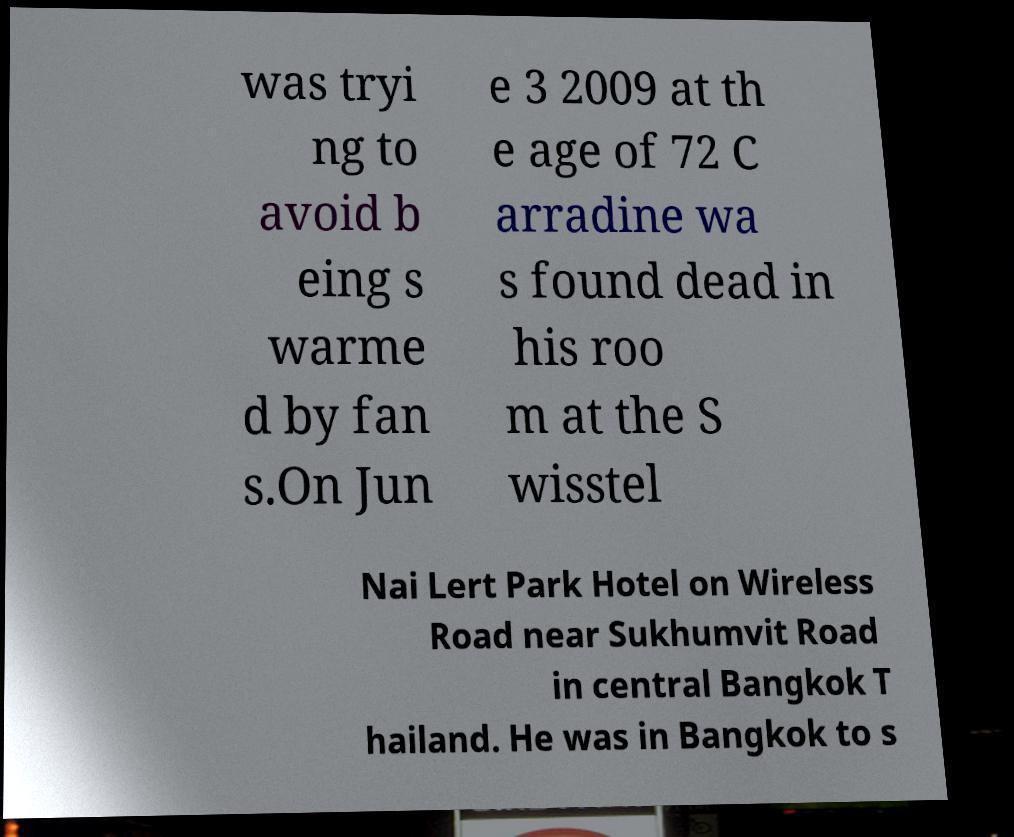I need the written content from this picture converted into text. Can you do that? was tryi ng to avoid b eing s warme d by fan s.On Jun e 3 2009 at th e age of 72 C arradine wa s found dead in his roo m at the S wisstel Nai Lert Park Hotel on Wireless Road near Sukhumvit Road in central Bangkok T hailand. He was in Bangkok to s 